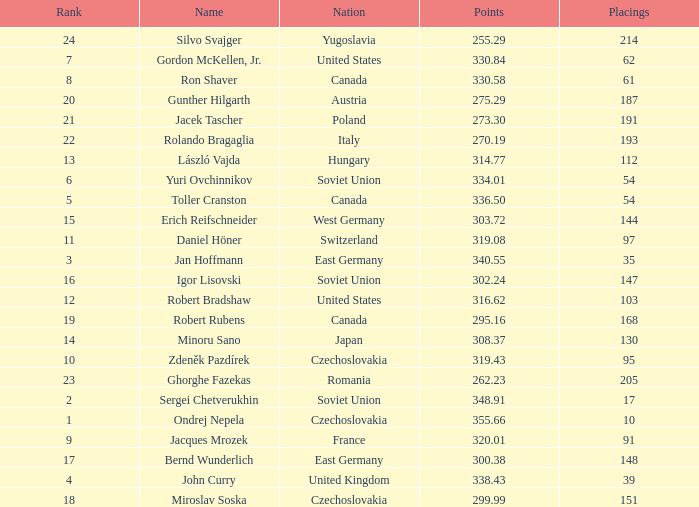How many Placings have Points smaller than 330.84, and a Name of silvo svajger? 1.0. 